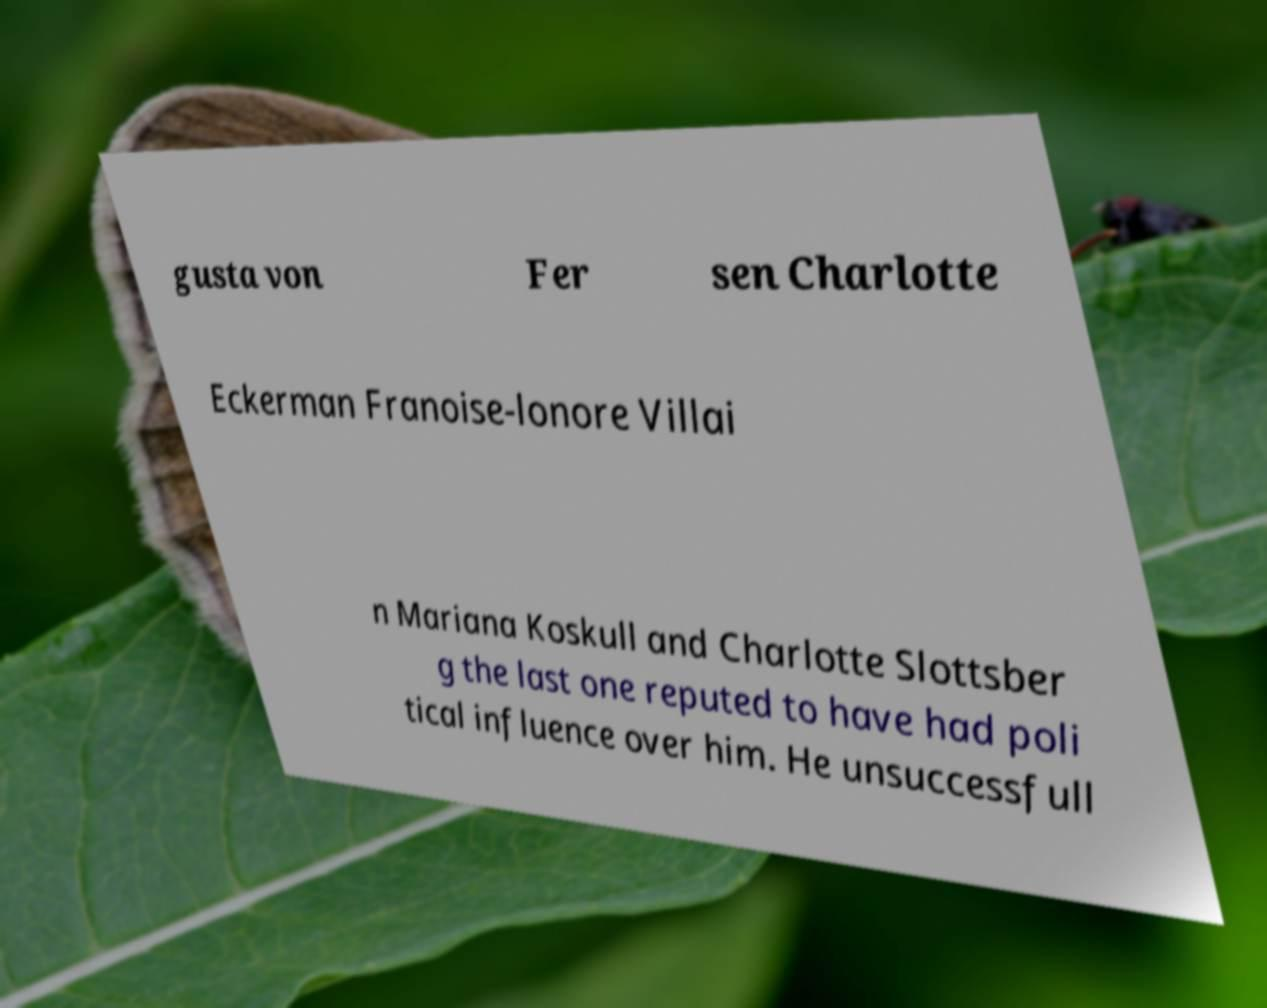Can you read and provide the text displayed in the image?This photo seems to have some interesting text. Can you extract and type it out for me? gusta von Fer sen Charlotte Eckerman Franoise-lonore Villai n Mariana Koskull and Charlotte Slottsber g the last one reputed to have had poli tical influence over him. He unsuccessfull 